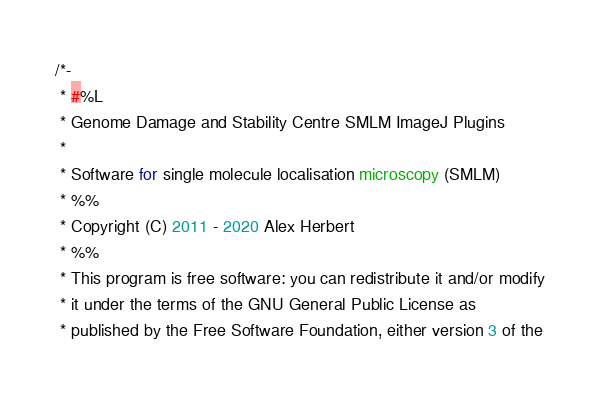Convert code to text. <code><loc_0><loc_0><loc_500><loc_500><_Java_>/*-
 * #%L
 * Genome Damage and Stability Centre SMLM ImageJ Plugins
 *
 * Software for single molecule localisation microscopy (SMLM)
 * %%
 * Copyright (C) 2011 - 2020 Alex Herbert
 * %%
 * This program is free software: you can redistribute it and/or modify
 * it under the terms of the GNU General Public License as
 * published by the Free Software Foundation, either version 3 of the</code> 